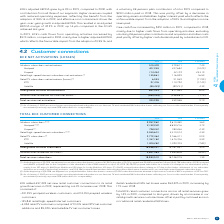According to Bce's financial document, How many subscribers were removed upon adjusting the wireless subscriber base in 2019? According to the financial document, 167,929. The relevant text states: "e adjusted our wireless subscriber base to remove 167,929 subscribers (72,231 postpaid and 95,698 prepaid) as follows: (A) 65,798 subscribers (19,195 postpai..." Also, How many IPTV subscribers were there in 2018? According to the financial document, 1,675,706. The relevant text states: "IPTV 1,767,182 1,675,706 5.5%..." Also, How many Satellite subscribers were there in 2019? According to the financial document, 1,005,282. The relevant text states: "Satellite 1,005,282 1,090,705 (7.8%)..." Also, can you calculate: What is the percentage of prepaid subscribers out of the wireless subscribers in 2019? Based on the calculation: 798,022/9,957,962, the result is 8.01 (percentage). This is based on the information: "Wireless subscribers (1) (2) 9,957,962 9,610,482 3.6% Prepaid (1) 798,022 780,266 2.3%..." The key data points involved are: 798,022, 9,957,962. Also, can you calculate: What is the change in the number of total services subscribers in 2019? Based on the calculation: 18,983,510-18,748,075, the result is 235435. This is based on the information: "Total services subscribers 18,983,510 18,748,075 1.3% Total services subscribers 18,983,510 18,748,075 1.3%..." The key data points involved are: 18,748,075, 18,983,510. Also, can you calculate: What is the percentage of Satellite subscribers out of the total number of subscribers in 2019? Based on the calculation: 1,005,282/18,983,510, the result is 5.3 (percentage). This is based on the information: "Total services subscribers 18,983,510 18,748,075 1.3% Satellite 1,005,282 1,090,705 (7.8%)..." The key data points involved are: 1,005,282, 18,983,510. 